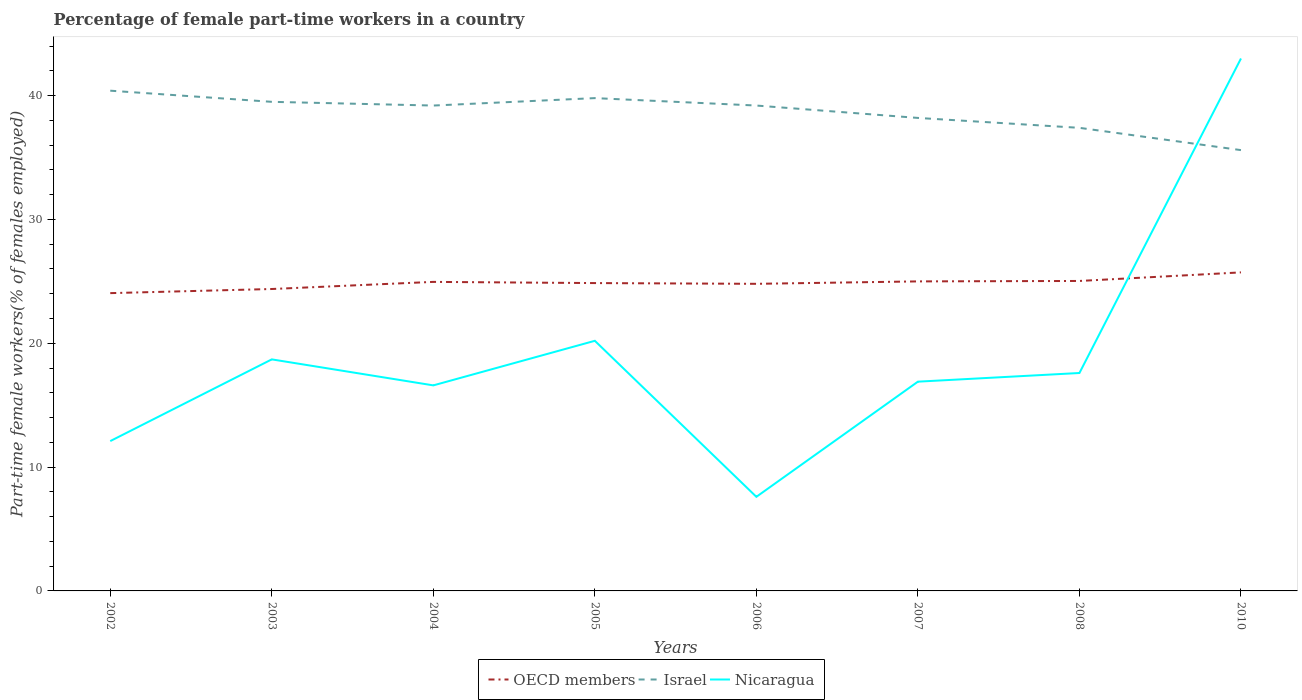How many different coloured lines are there?
Give a very brief answer. 3. Does the line corresponding to OECD members intersect with the line corresponding to Nicaragua?
Offer a very short reply. Yes. Is the number of lines equal to the number of legend labels?
Your response must be concise. Yes. Across all years, what is the maximum percentage of female part-time workers in Nicaragua?
Ensure brevity in your answer.  7.6. In which year was the percentage of female part-time workers in OECD members maximum?
Offer a terse response. 2002. What is the total percentage of female part-time workers in Nicaragua in the graph?
Offer a very short reply. -22.8. What is the difference between the highest and the second highest percentage of female part-time workers in Israel?
Keep it short and to the point. 4.8. How many lines are there?
Your answer should be compact. 3. How many years are there in the graph?
Give a very brief answer. 8. What is the difference between two consecutive major ticks on the Y-axis?
Your answer should be compact. 10. Does the graph contain any zero values?
Offer a very short reply. No. Does the graph contain grids?
Make the answer very short. No. How are the legend labels stacked?
Ensure brevity in your answer.  Horizontal. What is the title of the graph?
Your answer should be very brief. Percentage of female part-time workers in a country. Does "Canada" appear as one of the legend labels in the graph?
Make the answer very short. No. What is the label or title of the X-axis?
Keep it short and to the point. Years. What is the label or title of the Y-axis?
Make the answer very short. Part-time female workers(% of females employed). What is the Part-time female workers(% of females employed) of OECD members in 2002?
Your response must be concise. 24.05. What is the Part-time female workers(% of females employed) in Israel in 2002?
Your answer should be compact. 40.4. What is the Part-time female workers(% of females employed) in Nicaragua in 2002?
Your answer should be compact. 12.1. What is the Part-time female workers(% of females employed) in OECD members in 2003?
Your response must be concise. 24.38. What is the Part-time female workers(% of females employed) of Israel in 2003?
Ensure brevity in your answer.  39.5. What is the Part-time female workers(% of females employed) in Nicaragua in 2003?
Your response must be concise. 18.7. What is the Part-time female workers(% of females employed) in OECD members in 2004?
Provide a short and direct response. 24.96. What is the Part-time female workers(% of females employed) in Israel in 2004?
Make the answer very short. 39.2. What is the Part-time female workers(% of females employed) in Nicaragua in 2004?
Keep it short and to the point. 16.6. What is the Part-time female workers(% of females employed) of OECD members in 2005?
Keep it short and to the point. 24.86. What is the Part-time female workers(% of females employed) in Israel in 2005?
Keep it short and to the point. 39.8. What is the Part-time female workers(% of females employed) of Nicaragua in 2005?
Your answer should be very brief. 20.2. What is the Part-time female workers(% of females employed) in OECD members in 2006?
Provide a short and direct response. 24.8. What is the Part-time female workers(% of females employed) of Israel in 2006?
Keep it short and to the point. 39.2. What is the Part-time female workers(% of females employed) in Nicaragua in 2006?
Your response must be concise. 7.6. What is the Part-time female workers(% of females employed) of OECD members in 2007?
Offer a very short reply. 25. What is the Part-time female workers(% of females employed) in Israel in 2007?
Offer a terse response. 38.2. What is the Part-time female workers(% of females employed) of Nicaragua in 2007?
Offer a very short reply. 16.9. What is the Part-time female workers(% of females employed) in OECD members in 2008?
Your answer should be compact. 25.03. What is the Part-time female workers(% of females employed) of Israel in 2008?
Give a very brief answer. 37.4. What is the Part-time female workers(% of females employed) in Nicaragua in 2008?
Offer a terse response. 17.6. What is the Part-time female workers(% of females employed) of OECD members in 2010?
Provide a short and direct response. 25.73. What is the Part-time female workers(% of females employed) of Israel in 2010?
Offer a very short reply. 35.6. Across all years, what is the maximum Part-time female workers(% of females employed) of OECD members?
Keep it short and to the point. 25.73. Across all years, what is the maximum Part-time female workers(% of females employed) in Israel?
Provide a succinct answer. 40.4. Across all years, what is the minimum Part-time female workers(% of females employed) of OECD members?
Keep it short and to the point. 24.05. Across all years, what is the minimum Part-time female workers(% of females employed) of Israel?
Keep it short and to the point. 35.6. Across all years, what is the minimum Part-time female workers(% of females employed) of Nicaragua?
Provide a short and direct response. 7.6. What is the total Part-time female workers(% of females employed) of OECD members in the graph?
Make the answer very short. 198.81. What is the total Part-time female workers(% of females employed) of Israel in the graph?
Make the answer very short. 309.3. What is the total Part-time female workers(% of females employed) in Nicaragua in the graph?
Keep it short and to the point. 152.7. What is the difference between the Part-time female workers(% of females employed) in OECD members in 2002 and that in 2003?
Offer a terse response. -0.33. What is the difference between the Part-time female workers(% of females employed) in Israel in 2002 and that in 2003?
Provide a succinct answer. 0.9. What is the difference between the Part-time female workers(% of females employed) in OECD members in 2002 and that in 2004?
Provide a succinct answer. -0.91. What is the difference between the Part-time female workers(% of females employed) of Nicaragua in 2002 and that in 2004?
Your answer should be very brief. -4.5. What is the difference between the Part-time female workers(% of females employed) of OECD members in 2002 and that in 2005?
Offer a very short reply. -0.81. What is the difference between the Part-time female workers(% of females employed) of Israel in 2002 and that in 2005?
Give a very brief answer. 0.6. What is the difference between the Part-time female workers(% of females employed) in Nicaragua in 2002 and that in 2005?
Your answer should be compact. -8.1. What is the difference between the Part-time female workers(% of females employed) of OECD members in 2002 and that in 2006?
Provide a succinct answer. -0.75. What is the difference between the Part-time female workers(% of females employed) in OECD members in 2002 and that in 2007?
Provide a succinct answer. -0.95. What is the difference between the Part-time female workers(% of females employed) in OECD members in 2002 and that in 2008?
Keep it short and to the point. -0.98. What is the difference between the Part-time female workers(% of females employed) of Israel in 2002 and that in 2008?
Keep it short and to the point. 3. What is the difference between the Part-time female workers(% of females employed) in OECD members in 2002 and that in 2010?
Keep it short and to the point. -1.68. What is the difference between the Part-time female workers(% of females employed) in Nicaragua in 2002 and that in 2010?
Offer a very short reply. -30.9. What is the difference between the Part-time female workers(% of females employed) in OECD members in 2003 and that in 2004?
Offer a terse response. -0.57. What is the difference between the Part-time female workers(% of females employed) in Nicaragua in 2003 and that in 2004?
Offer a very short reply. 2.1. What is the difference between the Part-time female workers(% of females employed) in OECD members in 2003 and that in 2005?
Your answer should be compact. -0.48. What is the difference between the Part-time female workers(% of females employed) of Nicaragua in 2003 and that in 2005?
Make the answer very short. -1.5. What is the difference between the Part-time female workers(% of females employed) of OECD members in 2003 and that in 2006?
Give a very brief answer. -0.42. What is the difference between the Part-time female workers(% of females employed) of Israel in 2003 and that in 2006?
Offer a terse response. 0.3. What is the difference between the Part-time female workers(% of females employed) in Nicaragua in 2003 and that in 2006?
Keep it short and to the point. 11.1. What is the difference between the Part-time female workers(% of females employed) in OECD members in 2003 and that in 2007?
Your answer should be compact. -0.61. What is the difference between the Part-time female workers(% of females employed) in Nicaragua in 2003 and that in 2007?
Offer a very short reply. 1.8. What is the difference between the Part-time female workers(% of females employed) of OECD members in 2003 and that in 2008?
Ensure brevity in your answer.  -0.65. What is the difference between the Part-time female workers(% of females employed) of Nicaragua in 2003 and that in 2008?
Provide a succinct answer. 1.1. What is the difference between the Part-time female workers(% of females employed) in OECD members in 2003 and that in 2010?
Offer a very short reply. -1.34. What is the difference between the Part-time female workers(% of females employed) of Israel in 2003 and that in 2010?
Make the answer very short. 3.9. What is the difference between the Part-time female workers(% of females employed) of Nicaragua in 2003 and that in 2010?
Your answer should be compact. -24.3. What is the difference between the Part-time female workers(% of females employed) of OECD members in 2004 and that in 2005?
Give a very brief answer. 0.1. What is the difference between the Part-time female workers(% of females employed) of Israel in 2004 and that in 2005?
Give a very brief answer. -0.6. What is the difference between the Part-time female workers(% of females employed) in Nicaragua in 2004 and that in 2005?
Make the answer very short. -3.6. What is the difference between the Part-time female workers(% of females employed) of OECD members in 2004 and that in 2006?
Ensure brevity in your answer.  0.16. What is the difference between the Part-time female workers(% of females employed) in Israel in 2004 and that in 2006?
Give a very brief answer. 0. What is the difference between the Part-time female workers(% of females employed) in Nicaragua in 2004 and that in 2006?
Keep it short and to the point. 9. What is the difference between the Part-time female workers(% of females employed) of OECD members in 2004 and that in 2007?
Offer a terse response. -0.04. What is the difference between the Part-time female workers(% of females employed) in Israel in 2004 and that in 2007?
Your response must be concise. 1. What is the difference between the Part-time female workers(% of females employed) in OECD members in 2004 and that in 2008?
Make the answer very short. -0.07. What is the difference between the Part-time female workers(% of females employed) in Nicaragua in 2004 and that in 2008?
Give a very brief answer. -1. What is the difference between the Part-time female workers(% of females employed) of OECD members in 2004 and that in 2010?
Offer a terse response. -0.77. What is the difference between the Part-time female workers(% of females employed) of Israel in 2004 and that in 2010?
Offer a terse response. 3.6. What is the difference between the Part-time female workers(% of females employed) of Nicaragua in 2004 and that in 2010?
Ensure brevity in your answer.  -26.4. What is the difference between the Part-time female workers(% of females employed) of OECD members in 2005 and that in 2006?
Make the answer very short. 0.06. What is the difference between the Part-time female workers(% of females employed) of Israel in 2005 and that in 2006?
Provide a succinct answer. 0.6. What is the difference between the Part-time female workers(% of females employed) in Nicaragua in 2005 and that in 2006?
Offer a very short reply. 12.6. What is the difference between the Part-time female workers(% of females employed) of OECD members in 2005 and that in 2007?
Ensure brevity in your answer.  -0.14. What is the difference between the Part-time female workers(% of females employed) of OECD members in 2005 and that in 2008?
Ensure brevity in your answer.  -0.17. What is the difference between the Part-time female workers(% of females employed) in Israel in 2005 and that in 2008?
Offer a terse response. 2.4. What is the difference between the Part-time female workers(% of females employed) of OECD members in 2005 and that in 2010?
Make the answer very short. -0.86. What is the difference between the Part-time female workers(% of females employed) in Nicaragua in 2005 and that in 2010?
Ensure brevity in your answer.  -22.8. What is the difference between the Part-time female workers(% of females employed) in OECD members in 2006 and that in 2007?
Ensure brevity in your answer.  -0.2. What is the difference between the Part-time female workers(% of females employed) of Israel in 2006 and that in 2007?
Ensure brevity in your answer.  1. What is the difference between the Part-time female workers(% of females employed) in Nicaragua in 2006 and that in 2007?
Provide a short and direct response. -9.3. What is the difference between the Part-time female workers(% of females employed) in OECD members in 2006 and that in 2008?
Ensure brevity in your answer.  -0.23. What is the difference between the Part-time female workers(% of females employed) of OECD members in 2006 and that in 2010?
Your answer should be very brief. -0.92. What is the difference between the Part-time female workers(% of females employed) of Israel in 2006 and that in 2010?
Provide a short and direct response. 3.6. What is the difference between the Part-time female workers(% of females employed) of Nicaragua in 2006 and that in 2010?
Ensure brevity in your answer.  -35.4. What is the difference between the Part-time female workers(% of females employed) of OECD members in 2007 and that in 2008?
Ensure brevity in your answer.  -0.03. What is the difference between the Part-time female workers(% of females employed) of OECD members in 2007 and that in 2010?
Your answer should be compact. -0.73. What is the difference between the Part-time female workers(% of females employed) in Nicaragua in 2007 and that in 2010?
Give a very brief answer. -26.1. What is the difference between the Part-time female workers(% of females employed) in OECD members in 2008 and that in 2010?
Ensure brevity in your answer.  -0.69. What is the difference between the Part-time female workers(% of females employed) of Nicaragua in 2008 and that in 2010?
Offer a terse response. -25.4. What is the difference between the Part-time female workers(% of females employed) of OECD members in 2002 and the Part-time female workers(% of females employed) of Israel in 2003?
Your answer should be very brief. -15.45. What is the difference between the Part-time female workers(% of females employed) in OECD members in 2002 and the Part-time female workers(% of females employed) in Nicaragua in 2003?
Give a very brief answer. 5.35. What is the difference between the Part-time female workers(% of females employed) in Israel in 2002 and the Part-time female workers(% of females employed) in Nicaragua in 2003?
Your answer should be very brief. 21.7. What is the difference between the Part-time female workers(% of females employed) in OECD members in 2002 and the Part-time female workers(% of females employed) in Israel in 2004?
Ensure brevity in your answer.  -15.15. What is the difference between the Part-time female workers(% of females employed) in OECD members in 2002 and the Part-time female workers(% of females employed) in Nicaragua in 2004?
Keep it short and to the point. 7.45. What is the difference between the Part-time female workers(% of females employed) in Israel in 2002 and the Part-time female workers(% of females employed) in Nicaragua in 2004?
Your answer should be compact. 23.8. What is the difference between the Part-time female workers(% of females employed) in OECD members in 2002 and the Part-time female workers(% of females employed) in Israel in 2005?
Give a very brief answer. -15.75. What is the difference between the Part-time female workers(% of females employed) of OECD members in 2002 and the Part-time female workers(% of females employed) of Nicaragua in 2005?
Give a very brief answer. 3.85. What is the difference between the Part-time female workers(% of females employed) in Israel in 2002 and the Part-time female workers(% of females employed) in Nicaragua in 2005?
Your answer should be very brief. 20.2. What is the difference between the Part-time female workers(% of females employed) of OECD members in 2002 and the Part-time female workers(% of females employed) of Israel in 2006?
Offer a very short reply. -15.15. What is the difference between the Part-time female workers(% of females employed) in OECD members in 2002 and the Part-time female workers(% of females employed) in Nicaragua in 2006?
Offer a terse response. 16.45. What is the difference between the Part-time female workers(% of females employed) of Israel in 2002 and the Part-time female workers(% of females employed) of Nicaragua in 2006?
Ensure brevity in your answer.  32.8. What is the difference between the Part-time female workers(% of females employed) of OECD members in 2002 and the Part-time female workers(% of females employed) of Israel in 2007?
Make the answer very short. -14.15. What is the difference between the Part-time female workers(% of females employed) in OECD members in 2002 and the Part-time female workers(% of females employed) in Nicaragua in 2007?
Your answer should be compact. 7.15. What is the difference between the Part-time female workers(% of females employed) in Israel in 2002 and the Part-time female workers(% of females employed) in Nicaragua in 2007?
Give a very brief answer. 23.5. What is the difference between the Part-time female workers(% of females employed) in OECD members in 2002 and the Part-time female workers(% of females employed) in Israel in 2008?
Your answer should be compact. -13.35. What is the difference between the Part-time female workers(% of females employed) of OECD members in 2002 and the Part-time female workers(% of females employed) of Nicaragua in 2008?
Your answer should be compact. 6.45. What is the difference between the Part-time female workers(% of females employed) of Israel in 2002 and the Part-time female workers(% of females employed) of Nicaragua in 2008?
Your answer should be compact. 22.8. What is the difference between the Part-time female workers(% of females employed) of OECD members in 2002 and the Part-time female workers(% of females employed) of Israel in 2010?
Your answer should be very brief. -11.55. What is the difference between the Part-time female workers(% of females employed) in OECD members in 2002 and the Part-time female workers(% of females employed) in Nicaragua in 2010?
Your answer should be compact. -18.95. What is the difference between the Part-time female workers(% of females employed) in OECD members in 2003 and the Part-time female workers(% of females employed) in Israel in 2004?
Keep it short and to the point. -14.82. What is the difference between the Part-time female workers(% of females employed) in OECD members in 2003 and the Part-time female workers(% of females employed) in Nicaragua in 2004?
Give a very brief answer. 7.78. What is the difference between the Part-time female workers(% of females employed) of Israel in 2003 and the Part-time female workers(% of females employed) of Nicaragua in 2004?
Your answer should be compact. 22.9. What is the difference between the Part-time female workers(% of females employed) in OECD members in 2003 and the Part-time female workers(% of females employed) in Israel in 2005?
Your response must be concise. -15.42. What is the difference between the Part-time female workers(% of females employed) of OECD members in 2003 and the Part-time female workers(% of females employed) of Nicaragua in 2005?
Your response must be concise. 4.18. What is the difference between the Part-time female workers(% of females employed) in Israel in 2003 and the Part-time female workers(% of females employed) in Nicaragua in 2005?
Your response must be concise. 19.3. What is the difference between the Part-time female workers(% of females employed) of OECD members in 2003 and the Part-time female workers(% of females employed) of Israel in 2006?
Make the answer very short. -14.82. What is the difference between the Part-time female workers(% of females employed) in OECD members in 2003 and the Part-time female workers(% of females employed) in Nicaragua in 2006?
Your answer should be very brief. 16.78. What is the difference between the Part-time female workers(% of females employed) of Israel in 2003 and the Part-time female workers(% of females employed) of Nicaragua in 2006?
Offer a very short reply. 31.9. What is the difference between the Part-time female workers(% of females employed) of OECD members in 2003 and the Part-time female workers(% of females employed) of Israel in 2007?
Your answer should be compact. -13.82. What is the difference between the Part-time female workers(% of females employed) in OECD members in 2003 and the Part-time female workers(% of females employed) in Nicaragua in 2007?
Provide a succinct answer. 7.48. What is the difference between the Part-time female workers(% of females employed) of Israel in 2003 and the Part-time female workers(% of females employed) of Nicaragua in 2007?
Your response must be concise. 22.6. What is the difference between the Part-time female workers(% of females employed) of OECD members in 2003 and the Part-time female workers(% of females employed) of Israel in 2008?
Your response must be concise. -13.02. What is the difference between the Part-time female workers(% of females employed) in OECD members in 2003 and the Part-time female workers(% of females employed) in Nicaragua in 2008?
Your answer should be compact. 6.78. What is the difference between the Part-time female workers(% of females employed) in Israel in 2003 and the Part-time female workers(% of females employed) in Nicaragua in 2008?
Provide a succinct answer. 21.9. What is the difference between the Part-time female workers(% of females employed) of OECD members in 2003 and the Part-time female workers(% of females employed) of Israel in 2010?
Offer a very short reply. -11.22. What is the difference between the Part-time female workers(% of females employed) in OECD members in 2003 and the Part-time female workers(% of females employed) in Nicaragua in 2010?
Offer a very short reply. -18.62. What is the difference between the Part-time female workers(% of females employed) in Israel in 2003 and the Part-time female workers(% of females employed) in Nicaragua in 2010?
Your response must be concise. -3.5. What is the difference between the Part-time female workers(% of females employed) in OECD members in 2004 and the Part-time female workers(% of females employed) in Israel in 2005?
Your answer should be very brief. -14.84. What is the difference between the Part-time female workers(% of females employed) of OECD members in 2004 and the Part-time female workers(% of females employed) of Nicaragua in 2005?
Ensure brevity in your answer.  4.76. What is the difference between the Part-time female workers(% of females employed) in OECD members in 2004 and the Part-time female workers(% of females employed) in Israel in 2006?
Your answer should be very brief. -14.24. What is the difference between the Part-time female workers(% of females employed) in OECD members in 2004 and the Part-time female workers(% of females employed) in Nicaragua in 2006?
Offer a terse response. 17.36. What is the difference between the Part-time female workers(% of females employed) in Israel in 2004 and the Part-time female workers(% of females employed) in Nicaragua in 2006?
Keep it short and to the point. 31.6. What is the difference between the Part-time female workers(% of females employed) of OECD members in 2004 and the Part-time female workers(% of females employed) of Israel in 2007?
Your response must be concise. -13.24. What is the difference between the Part-time female workers(% of females employed) in OECD members in 2004 and the Part-time female workers(% of females employed) in Nicaragua in 2007?
Keep it short and to the point. 8.06. What is the difference between the Part-time female workers(% of females employed) of Israel in 2004 and the Part-time female workers(% of females employed) of Nicaragua in 2007?
Provide a succinct answer. 22.3. What is the difference between the Part-time female workers(% of females employed) of OECD members in 2004 and the Part-time female workers(% of females employed) of Israel in 2008?
Your response must be concise. -12.44. What is the difference between the Part-time female workers(% of females employed) in OECD members in 2004 and the Part-time female workers(% of females employed) in Nicaragua in 2008?
Keep it short and to the point. 7.36. What is the difference between the Part-time female workers(% of females employed) of Israel in 2004 and the Part-time female workers(% of females employed) of Nicaragua in 2008?
Give a very brief answer. 21.6. What is the difference between the Part-time female workers(% of females employed) of OECD members in 2004 and the Part-time female workers(% of females employed) of Israel in 2010?
Your answer should be compact. -10.64. What is the difference between the Part-time female workers(% of females employed) of OECD members in 2004 and the Part-time female workers(% of females employed) of Nicaragua in 2010?
Give a very brief answer. -18.04. What is the difference between the Part-time female workers(% of females employed) in Israel in 2004 and the Part-time female workers(% of females employed) in Nicaragua in 2010?
Keep it short and to the point. -3.8. What is the difference between the Part-time female workers(% of females employed) of OECD members in 2005 and the Part-time female workers(% of females employed) of Israel in 2006?
Keep it short and to the point. -14.34. What is the difference between the Part-time female workers(% of females employed) of OECD members in 2005 and the Part-time female workers(% of females employed) of Nicaragua in 2006?
Offer a very short reply. 17.26. What is the difference between the Part-time female workers(% of females employed) in Israel in 2005 and the Part-time female workers(% of females employed) in Nicaragua in 2006?
Offer a very short reply. 32.2. What is the difference between the Part-time female workers(% of females employed) of OECD members in 2005 and the Part-time female workers(% of females employed) of Israel in 2007?
Your response must be concise. -13.34. What is the difference between the Part-time female workers(% of females employed) in OECD members in 2005 and the Part-time female workers(% of females employed) in Nicaragua in 2007?
Provide a short and direct response. 7.96. What is the difference between the Part-time female workers(% of females employed) in Israel in 2005 and the Part-time female workers(% of females employed) in Nicaragua in 2007?
Make the answer very short. 22.9. What is the difference between the Part-time female workers(% of females employed) in OECD members in 2005 and the Part-time female workers(% of females employed) in Israel in 2008?
Make the answer very short. -12.54. What is the difference between the Part-time female workers(% of females employed) of OECD members in 2005 and the Part-time female workers(% of females employed) of Nicaragua in 2008?
Give a very brief answer. 7.26. What is the difference between the Part-time female workers(% of females employed) in OECD members in 2005 and the Part-time female workers(% of females employed) in Israel in 2010?
Provide a succinct answer. -10.74. What is the difference between the Part-time female workers(% of females employed) of OECD members in 2005 and the Part-time female workers(% of females employed) of Nicaragua in 2010?
Offer a terse response. -18.14. What is the difference between the Part-time female workers(% of females employed) in OECD members in 2006 and the Part-time female workers(% of females employed) in Israel in 2007?
Give a very brief answer. -13.4. What is the difference between the Part-time female workers(% of females employed) of OECD members in 2006 and the Part-time female workers(% of females employed) of Nicaragua in 2007?
Your response must be concise. 7.9. What is the difference between the Part-time female workers(% of females employed) of Israel in 2006 and the Part-time female workers(% of females employed) of Nicaragua in 2007?
Your answer should be very brief. 22.3. What is the difference between the Part-time female workers(% of females employed) in OECD members in 2006 and the Part-time female workers(% of females employed) in Israel in 2008?
Ensure brevity in your answer.  -12.6. What is the difference between the Part-time female workers(% of females employed) in OECD members in 2006 and the Part-time female workers(% of females employed) in Nicaragua in 2008?
Offer a terse response. 7.2. What is the difference between the Part-time female workers(% of females employed) of Israel in 2006 and the Part-time female workers(% of females employed) of Nicaragua in 2008?
Offer a terse response. 21.6. What is the difference between the Part-time female workers(% of females employed) in OECD members in 2006 and the Part-time female workers(% of females employed) in Israel in 2010?
Give a very brief answer. -10.8. What is the difference between the Part-time female workers(% of females employed) of OECD members in 2006 and the Part-time female workers(% of females employed) of Nicaragua in 2010?
Provide a succinct answer. -18.2. What is the difference between the Part-time female workers(% of females employed) of OECD members in 2007 and the Part-time female workers(% of females employed) of Israel in 2008?
Give a very brief answer. -12.4. What is the difference between the Part-time female workers(% of females employed) of OECD members in 2007 and the Part-time female workers(% of females employed) of Nicaragua in 2008?
Make the answer very short. 7.4. What is the difference between the Part-time female workers(% of females employed) of Israel in 2007 and the Part-time female workers(% of females employed) of Nicaragua in 2008?
Keep it short and to the point. 20.6. What is the difference between the Part-time female workers(% of females employed) in OECD members in 2007 and the Part-time female workers(% of females employed) in Israel in 2010?
Ensure brevity in your answer.  -10.6. What is the difference between the Part-time female workers(% of females employed) of OECD members in 2007 and the Part-time female workers(% of females employed) of Nicaragua in 2010?
Your response must be concise. -18. What is the difference between the Part-time female workers(% of females employed) in Israel in 2007 and the Part-time female workers(% of females employed) in Nicaragua in 2010?
Keep it short and to the point. -4.8. What is the difference between the Part-time female workers(% of females employed) in OECD members in 2008 and the Part-time female workers(% of females employed) in Israel in 2010?
Make the answer very short. -10.57. What is the difference between the Part-time female workers(% of females employed) in OECD members in 2008 and the Part-time female workers(% of females employed) in Nicaragua in 2010?
Your answer should be compact. -17.97. What is the difference between the Part-time female workers(% of females employed) of Israel in 2008 and the Part-time female workers(% of females employed) of Nicaragua in 2010?
Ensure brevity in your answer.  -5.6. What is the average Part-time female workers(% of females employed) in OECD members per year?
Offer a terse response. 24.85. What is the average Part-time female workers(% of females employed) of Israel per year?
Give a very brief answer. 38.66. What is the average Part-time female workers(% of females employed) in Nicaragua per year?
Ensure brevity in your answer.  19.09. In the year 2002, what is the difference between the Part-time female workers(% of females employed) of OECD members and Part-time female workers(% of females employed) of Israel?
Provide a succinct answer. -16.35. In the year 2002, what is the difference between the Part-time female workers(% of females employed) of OECD members and Part-time female workers(% of females employed) of Nicaragua?
Provide a short and direct response. 11.95. In the year 2002, what is the difference between the Part-time female workers(% of females employed) of Israel and Part-time female workers(% of females employed) of Nicaragua?
Make the answer very short. 28.3. In the year 2003, what is the difference between the Part-time female workers(% of females employed) of OECD members and Part-time female workers(% of females employed) of Israel?
Provide a succinct answer. -15.12. In the year 2003, what is the difference between the Part-time female workers(% of females employed) in OECD members and Part-time female workers(% of females employed) in Nicaragua?
Give a very brief answer. 5.68. In the year 2003, what is the difference between the Part-time female workers(% of females employed) in Israel and Part-time female workers(% of females employed) in Nicaragua?
Your answer should be very brief. 20.8. In the year 2004, what is the difference between the Part-time female workers(% of females employed) of OECD members and Part-time female workers(% of females employed) of Israel?
Ensure brevity in your answer.  -14.24. In the year 2004, what is the difference between the Part-time female workers(% of females employed) of OECD members and Part-time female workers(% of females employed) of Nicaragua?
Give a very brief answer. 8.36. In the year 2004, what is the difference between the Part-time female workers(% of females employed) of Israel and Part-time female workers(% of females employed) of Nicaragua?
Make the answer very short. 22.6. In the year 2005, what is the difference between the Part-time female workers(% of females employed) of OECD members and Part-time female workers(% of females employed) of Israel?
Make the answer very short. -14.94. In the year 2005, what is the difference between the Part-time female workers(% of females employed) of OECD members and Part-time female workers(% of females employed) of Nicaragua?
Provide a short and direct response. 4.66. In the year 2005, what is the difference between the Part-time female workers(% of females employed) in Israel and Part-time female workers(% of females employed) in Nicaragua?
Your response must be concise. 19.6. In the year 2006, what is the difference between the Part-time female workers(% of females employed) of OECD members and Part-time female workers(% of females employed) of Israel?
Your response must be concise. -14.4. In the year 2006, what is the difference between the Part-time female workers(% of females employed) of OECD members and Part-time female workers(% of females employed) of Nicaragua?
Give a very brief answer. 17.2. In the year 2006, what is the difference between the Part-time female workers(% of females employed) in Israel and Part-time female workers(% of females employed) in Nicaragua?
Offer a terse response. 31.6. In the year 2007, what is the difference between the Part-time female workers(% of females employed) in OECD members and Part-time female workers(% of females employed) in Israel?
Your response must be concise. -13.2. In the year 2007, what is the difference between the Part-time female workers(% of females employed) of OECD members and Part-time female workers(% of females employed) of Nicaragua?
Your answer should be compact. 8.1. In the year 2007, what is the difference between the Part-time female workers(% of females employed) in Israel and Part-time female workers(% of females employed) in Nicaragua?
Your answer should be compact. 21.3. In the year 2008, what is the difference between the Part-time female workers(% of females employed) of OECD members and Part-time female workers(% of females employed) of Israel?
Keep it short and to the point. -12.37. In the year 2008, what is the difference between the Part-time female workers(% of females employed) in OECD members and Part-time female workers(% of females employed) in Nicaragua?
Give a very brief answer. 7.43. In the year 2008, what is the difference between the Part-time female workers(% of females employed) of Israel and Part-time female workers(% of females employed) of Nicaragua?
Offer a terse response. 19.8. In the year 2010, what is the difference between the Part-time female workers(% of females employed) in OECD members and Part-time female workers(% of females employed) in Israel?
Your answer should be very brief. -9.87. In the year 2010, what is the difference between the Part-time female workers(% of females employed) of OECD members and Part-time female workers(% of females employed) of Nicaragua?
Your answer should be compact. -17.27. In the year 2010, what is the difference between the Part-time female workers(% of females employed) of Israel and Part-time female workers(% of females employed) of Nicaragua?
Ensure brevity in your answer.  -7.4. What is the ratio of the Part-time female workers(% of females employed) of OECD members in 2002 to that in 2003?
Your answer should be compact. 0.99. What is the ratio of the Part-time female workers(% of females employed) of Israel in 2002 to that in 2003?
Offer a terse response. 1.02. What is the ratio of the Part-time female workers(% of females employed) in Nicaragua in 2002 to that in 2003?
Offer a terse response. 0.65. What is the ratio of the Part-time female workers(% of females employed) in OECD members in 2002 to that in 2004?
Offer a terse response. 0.96. What is the ratio of the Part-time female workers(% of females employed) in Israel in 2002 to that in 2004?
Offer a very short reply. 1.03. What is the ratio of the Part-time female workers(% of females employed) in Nicaragua in 2002 to that in 2004?
Keep it short and to the point. 0.73. What is the ratio of the Part-time female workers(% of females employed) in OECD members in 2002 to that in 2005?
Make the answer very short. 0.97. What is the ratio of the Part-time female workers(% of females employed) in Israel in 2002 to that in 2005?
Make the answer very short. 1.02. What is the ratio of the Part-time female workers(% of females employed) in Nicaragua in 2002 to that in 2005?
Make the answer very short. 0.6. What is the ratio of the Part-time female workers(% of females employed) of OECD members in 2002 to that in 2006?
Give a very brief answer. 0.97. What is the ratio of the Part-time female workers(% of females employed) of Israel in 2002 to that in 2006?
Your response must be concise. 1.03. What is the ratio of the Part-time female workers(% of females employed) in Nicaragua in 2002 to that in 2006?
Provide a succinct answer. 1.59. What is the ratio of the Part-time female workers(% of females employed) in OECD members in 2002 to that in 2007?
Offer a very short reply. 0.96. What is the ratio of the Part-time female workers(% of females employed) of Israel in 2002 to that in 2007?
Make the answer very short. 1.06. What is the ratio of the Part-time female workers(% of females employed) of Nicaragua in 2002 to that in 2007?
Provide a short and direct response. 0.72. What is the ratio of the Part-time female workers(% of females employed) of OECD members in 2002 to that in 2008?
Your answer should be compact. 0.96. What is the ratio of the Part-time female workers(% of females employed) of Israel in 2002 to that in 2008?
Offer a terse response. 1.08. What is the ratio of the Part-time female workers(% of females employed) of Nicaragua in 2002 to that in 2008?
Offer a terse response. 0.69. What is the ratio of the Part-time female workers(% of females employed) in OECD members in 2002 to that in 2010?
Keep it short and to the point. 0.93. What is the ratio of the Part-time female workers(% of females employed) of Israel in 2002 to that in 2010?
Provide a succinct answer. 1.13. What is the ratio of the Part-time female workers(% of females employed) in Nicaragua in 2002 to that in 2010?
Your answer should be very brief. 0.28. What is the ratio of the Part-time female workers(% of females employed) of Israel in 2003 to that in 2004?
Offer a terse response. 1.01. What is the ratio of the Part-time female workers(% of females employed) of Nicaragua in 2003 to that in 2004?
Give a very brief answer. 1.13. What is the ratio of the Part-time female workers(% of females employed) of OECD members in 2003 to that in 2005?
Provide a short and direct response. 0.98. What is the ratio of the Part-time female workers(% of females employed) of Nicaragua in 2003 to that in 2005?
Your answer should be very brief. 0.93. What is the ratio of the Part-time female workers(% of females employed) of OECD members in 2003 to that in 2006?
Make the answer very short. 0.98. What is the ratio of the Part-time female workers(% of females employed) of Israel in 2003 to that in 2006?
Provide a succinct answer. 1.01. What is the ratio of the Part-time female workers(% of females employed) in Nicaragua in 2003 to that in 2006?
Ensure brevity in your answer.  2.46. What is the ratio of the Part-time female workers(% of females employed) of OECD members in 2003 to that in 2007?
Provide a succinct answer. 0.98. What is the ratio of the Part-time female workers(% of females employed) of Israel in 2003 to that in 2007?
Provide a succinct answer. 1.03. What is the ratio of the Part-time female workers(% of females employed) of Nicaragua in 2003 to that in 2007?
Give a very brief answer. 1.11. What is the ratio of the Part-time female workers(% of females employed) in OECD members in 2003 to that in 2008?
Provide a short and direct response. 0.97. What is the ratio of the Part-time female workers(% of females employed) of Israel in 2003 to that in 2008?
Provide a succinct answer. 1.06. What is the ratio of the Part-time female workers(% of females employed) in OECD members in 2003 to that in 2010?
Provide a short and direct response. 0.95. What is the ratio of the Part-time female workers(% of females employed) in Israel in 2003 to that in 2010?
Make the answer very short. 1.11. What is the ratio of the Part-time female workers(% of females employed) in Nicaragua in 2003 to that in 2010?
Provide a short and direct response. 0.43. What is the ratio of the Part-time female workers(% of females employed) of OECD members in 2004 to that in 2005?
Ensure brevity in your answer.  1. What is the ratio of the Part-time female workers(% of females employed) of Israel in 2004 to that in 2005?
Offer a very short reply. 0.98. What is the ratio of the Part-time female workers(% of females employed) of Nicaragua in 2004 to that in 2005?
Give a very brief answer. 0.82. What is the ratio of the Part-time female workers(% of females employed) of Nicaragua in 2004 to that in 2006?
Your answer should be compact. 2.18. What is the ratio of the Part-time female workers(% of females employed) in Israel in 2004 to that in 2007?
Give a very brief answer. 1.03. What is the ratio of the Part-time female workers(% of females employed) of Nicaragua in 2004 to that in 2007?
Ensure brevity in your answer.  0.98. What is the ratio of the Part-time female workers(% of females employed) of OECD members in 2004 to that in 2008?
Provide a succinct answer. 1. What is the ratio of the Part-time female workers(% of females employed) of Israel in 2004 to that in 2008?
Provide a succinct answer. 1.05. What is the ratio of the Part-time female workers(% of females employed) in Nicaragua in 2004 to that in 2008?
Offer a very short reply. 0.94. What is the ratio of the Part-time female workers(% of females employed) of OECD members in 2004 to that in 2010?
Keep it short and to the point. 0.97. What is the ratio of the Part-time female workers(% of females employed) of Israel in 2004 to that in 2010?
Offer a very short reply. 1.1. What is the ratio of the Part-time female workers(% of females employed) in Nicaragua in 2004 to that in 2010?
Keep it short and to the point. 0.39. What is the ratio of the Part-time female workers(% of females employed) of Israel in 2005 to that in 2006?
Offer a very short reply. 1.02. What is the ratio of the Part-time female workers(% of females employed) in Nicaragua in 2005 to that in 2006?
Your answer should be very brief. 2.66. What is the ratio of the Part-time female workers(% of females employed) of Israel in 2005 to that in 2007?
Offer a very short reply. 1.04. What is the ratio of the Part-time female workers(% of females employed) in Nicaragua in 2005 to that in 2007?
Give a very brief answer. 1.2. What is the ratio of the Part-time female workers(% of females employed) in OECD members in 2005 to that in 2008?
Offer a very short reply. 0.99. What is the ratio of the Part-time female workers(% of females employed) in Israel in 2005 to that in 2008?
Ensure brevity in your answer.  1.06. What is the ratio of the Part-time female workers(% of females employed) in Nicaragua in 2005 to that in 2008?
Keep it short and to the point. 1.15. What is the ratio of the Part-time female workers(% of females employed) in OECD members in 2005 to that in 2010?
Offer a very short reply. 0.97. What is the ratio of the Part-time female workers(% of females employed) in Israel in 2005 to that in 2010?
Keep it short and to the point. 1.12. What is the ratio of the Part-time female workers(% of females employed) of Nicaragua in 2005 to that in 2010?
Your answer should be compact. 0.47. What is the ratio of the Part-time female workers(% of females employed) of Israel in 2006 to that in 2007?
Your answer should be very brief. 1.03. What is the ratio of the Part-time female workers(% of females employed) of Nicaragua in 2006 to that in 2007?
Keep it short and to the point. 0.45. What is the ratio of the Part-time female workers(% of females employed) of Israel in 2006 to that in 2008?
Make the answer very short. 1.05. What is the ratio of the Part-time female workers(% of females employed) of Nicaragua in 2006 to that in 2008?
Make the answer very short. 0.43. What is the ratio of the Part-time female workers(% of females employed) of OECD members in 2006 to that in 2010?
Offer a terse response. 0.96. What is the ratio of the Part-time female workers(% of females employed) of Israel in 2006 to that in 2010?
Provide a short and direct response. 1.1. What is the ratio of the Part-time female workers(% of females employed) of Nicaragua in 2006 to that in 2010?
Give a very brief answer. 0.18. What is the ratio of the Part-time female workers(% of females employed) of Israel in 2007 to that in 2008?
Offer a very short reply. 1.02. What is the ratio of the Part-time female workers(% of females employed) of Nicaragua in 2007 to that in 2008?
Your answer should be very brief. 0.96. What is the ratio of the Part-time female workers(% of females employed) in OECD members in 2007 to that in 2010?
Provide a short and direct response. 0.97. What is the ratio of the Part-time female workers(% of females employed) of Israel in 2007 to that in 2010?
Provide a short and direct response. 1.07. What is the ratio of the Part-time female workers(% of females employed) in Nicaragua in 2007 to that in 2010?
Your response must be concise. 0.39. What is the ratio of the Part-time female workers(% of females employed) in OECD members in 2008 to that in 2010?
Provide a short and direct response. 0.97. What is the ratio of the Part-time female workers(% of females employed) in Israel in 2008 to that in 2010?
Offer a terse response. 1.05. What is the ratio of the Part-time female workers(% of females employed) in Nicaragua in 2008 to that in 2010?
Your response must be concise. 0.41. What is the difference between the highest and the second highest Part-time female workers(% of females employed) of OECD members?
Your answer should be very brief. 0.69. What is the difference between the highest and the second highest Part-time female workers(% of females employed) of Nicaragua?
Your answer should be compact. 22.8. What is the difference between the highest and the lowest Part-time female workers(% of females employed) in OECD members?
Provide a short and direct response. 1.68. What is the difference between the highest and the lowest Part-time female workers(% of females employed) of Nicaragua?
Ensure brevity in your answer.  35.4. 